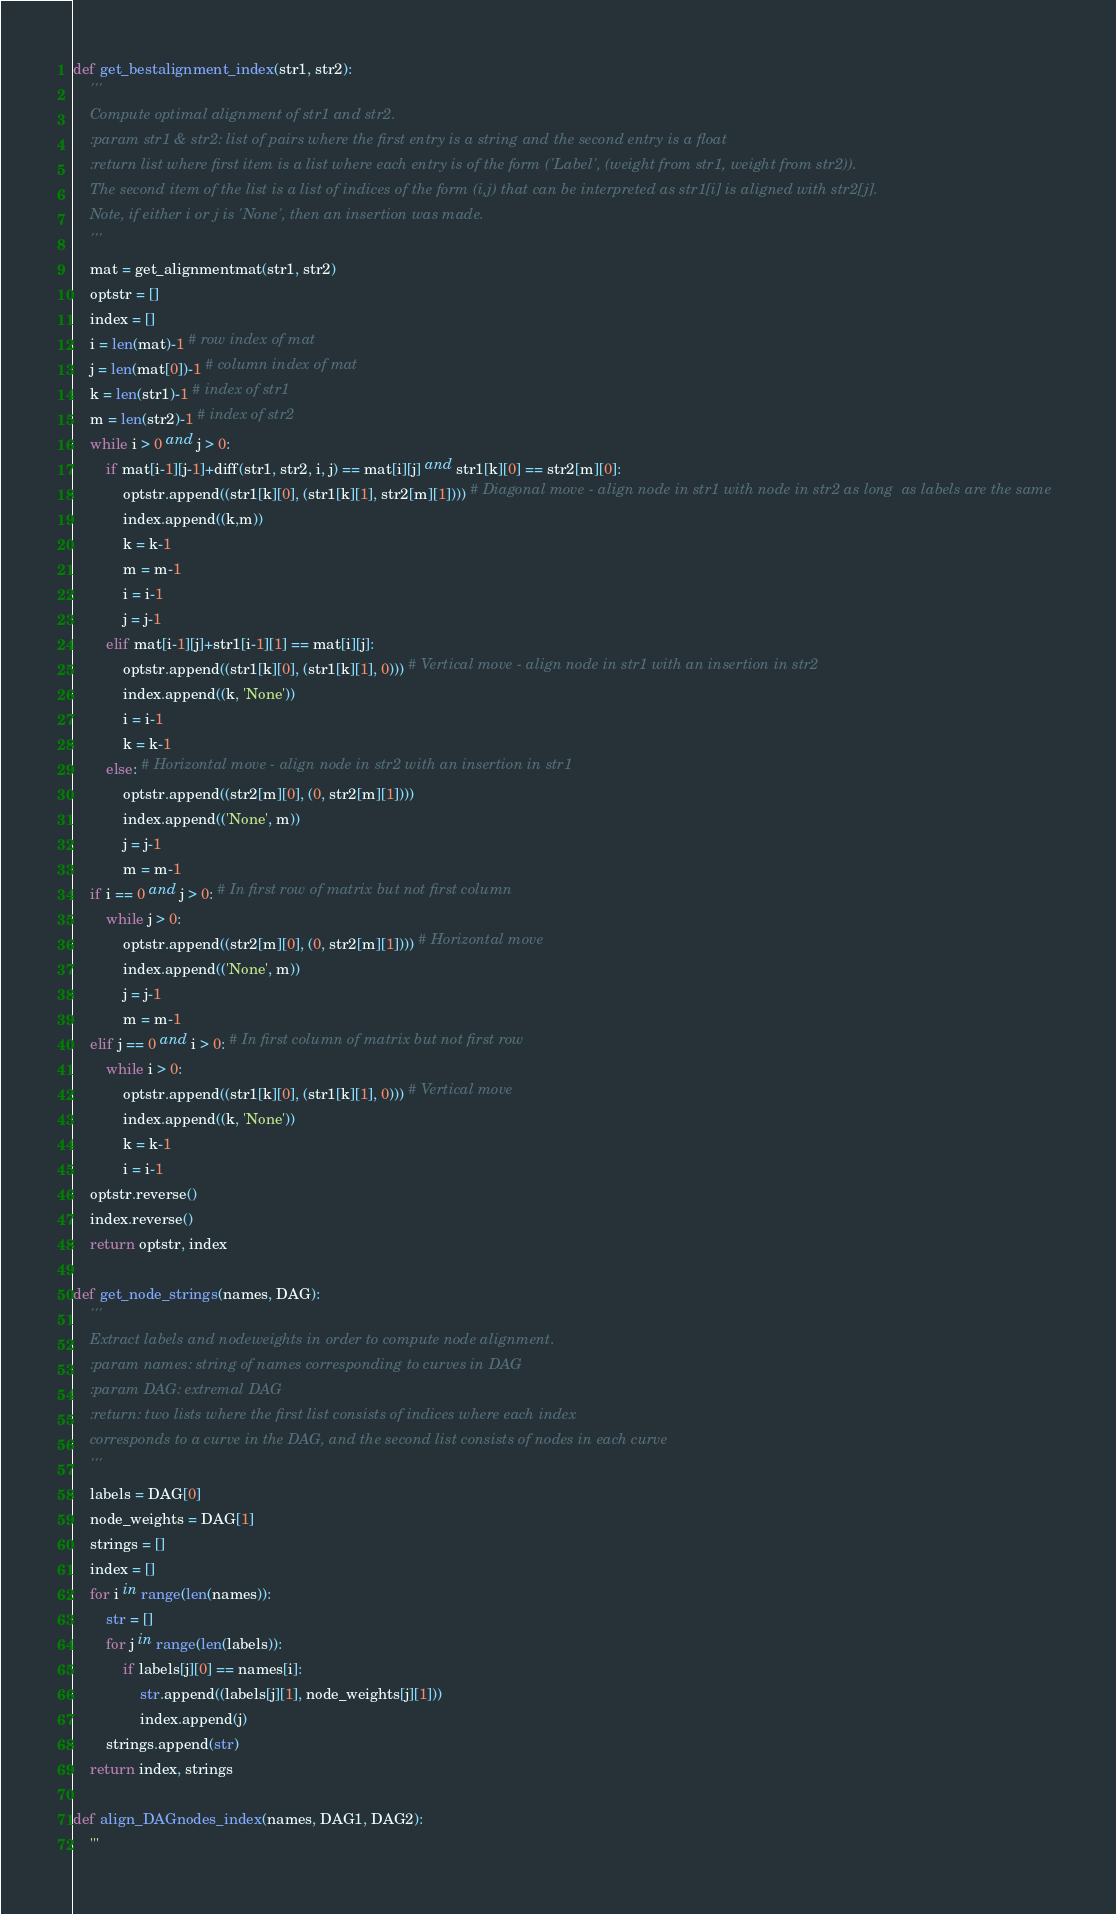<code> <loc_0><loc_0><loc_500><loc_500><_Python_>
def get_bestalignment_index(str1, str2):
    '''
    Compute optimal alignment of str1 and str2.
    :param str1 & str2: list of pairs where the first entry is a string and the second entry is a float
    :return list where first item is a list where each entry is of the form ('Label', (weight from str1, weight from str2)).
    The second item of the list is a list of indices of the form (i,j) that can be interpreted as str1[i] is aligned with str2[j].
    Note, if either i or j is 'None', then an insertion was made.
    '''
    mat = get_alignmentmat(str1, str2)
    optstr = []
    index = []
    i = len(mat)-1 # row index of mat
    j = len(mat[0])-1 # column index of mat
    k = len(str1)-1 # index of str1
    m = len(str2)-1 # index of str2
    while i > 0 and j > 0:
        if mat[i-1][j-1]+diff(str1, str2, i, j) == mat[i][j] and str1[k][0] == str2[m][0]:
            optstr.append((str1[k][0], (str1[k][1], str2[m][1]))) # Diagonal move - align node in str1 with node in str2 as long  as labels are the same
            index.append((k,m))
            k = k-1
            m = m-1
            i = i-1
            j = j-1
        elif mat[i-1][j]+str1[i-1][1] == mat[i][j]:
            optstr.append((str1[k][0], (str1[k][1], 0))) # Vertical move - align node in str1 with an insertion in str2
            index.append((k, 'None'))
            i = i-1
            k = k-1
        else: # Horizontal move - align node in str2 with an insertion in str1
            optstr.append((str2[m][0], (0, str2[m][1])))
            index.append(('None', m))
            j = j-1
            m = m-1
    if i == 0 and j > 0: # In first row of matrix but not first column
        while j > 0:
            optstr.append((str2[m][0], (0, str2[m][1]))) # Horizontal move
            index.append(('None', m))
            j = j-1
            m = m-1
    elif j == 0 and i > 0: # In first column of matrix but not first row
        while i > 0:
            optstr.append((str1[k][0], (str1[k][1], 0))) # Vertical move
            index.append((k, 'None'))
            k = k-1
            i = i-1
    optstr.reverse()
    index.reverse()
    return optstr, index

def get_node_strings(names, DAG): 
    '''
    Extract labels and nodeweights in order to compute node alignment.
    :param names: string of names corresponding to curves in DAG
    :param DAG: extremal DAG
    :return: two lists where the first list consists of indices where each index
    corresponds to a curve in the DAG, and the second list consists of nodes in each curve
    '''
    labels = DAG[0]
    node_weights = DAG[1]
    strings = []
    index = []
    for i in range(len(names)):
        str = []
        for j in range(len(labels)):
            if labels[j][0] == names[i]:
                str.append((labels[j][1], node_weights[j][1]))
                index.append(j)
        strings.append(str)
    return index, strings

def align_DAGnodes_index(names, DAG1, DAG2): 
    '''</code> 